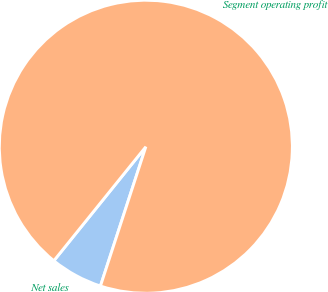Convert chart. <chart><loc_0><loc_0><loc_500><loc_500><pie_chart><fcel>Net sales<fcel>Segment operating profit<nl><fcel>5.79%<fcel>94.21%<nl></chart> 